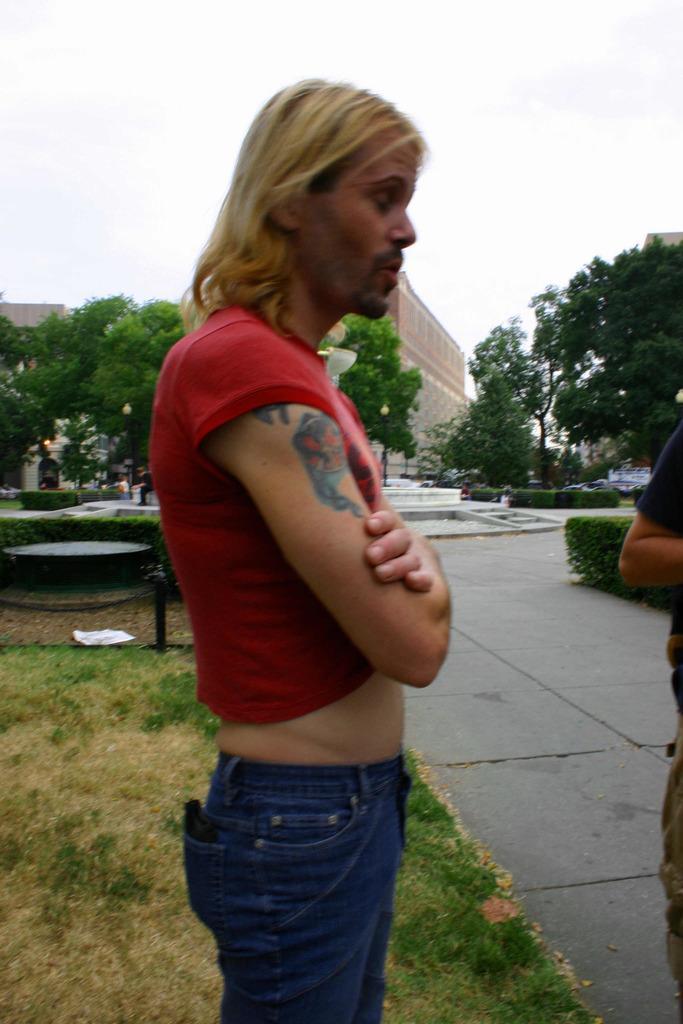In one or two sentences, can you explain what this image depicts? In this image we can see people. In the background there are trees, buildings and sky. At the bottom there is grass. 